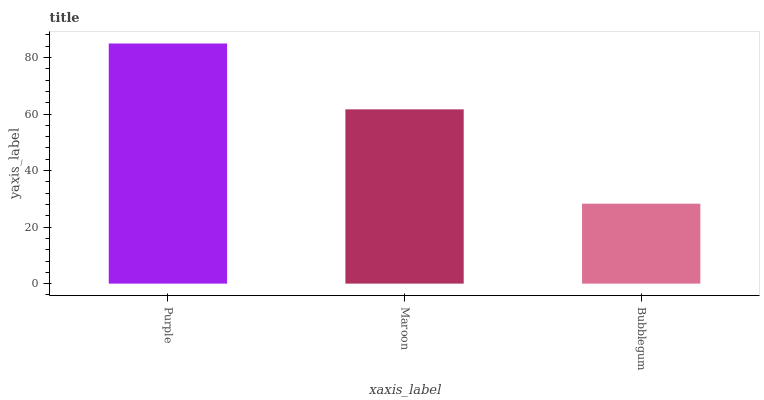Is Bubblegum the minimum?
Answer yes or no. Yes. Is Purple the maximum?
Answer yes or no. Yes. Is Maroon the minimum?
Answer yes or no. No. Is Maroon the maximum?
Answer yes or no. No. Is Purple greater than Maroon?
Answer yes or no. Yes. Is Maroon less than Purple?
Answer yes or no. Yes. Is Maroon greater than Purple?
Answer yes or no. No. Is Purple less than Maroon?
Answer yes or no. No. Is Maroon the high median?
Answer yes or no. Yes. Is Maroon the low median?
Answer yes or no. Yes. Is Purple the high median?
Answer yes or no. No. Is Bubblegum the low median?
Answer yes or no. No. 